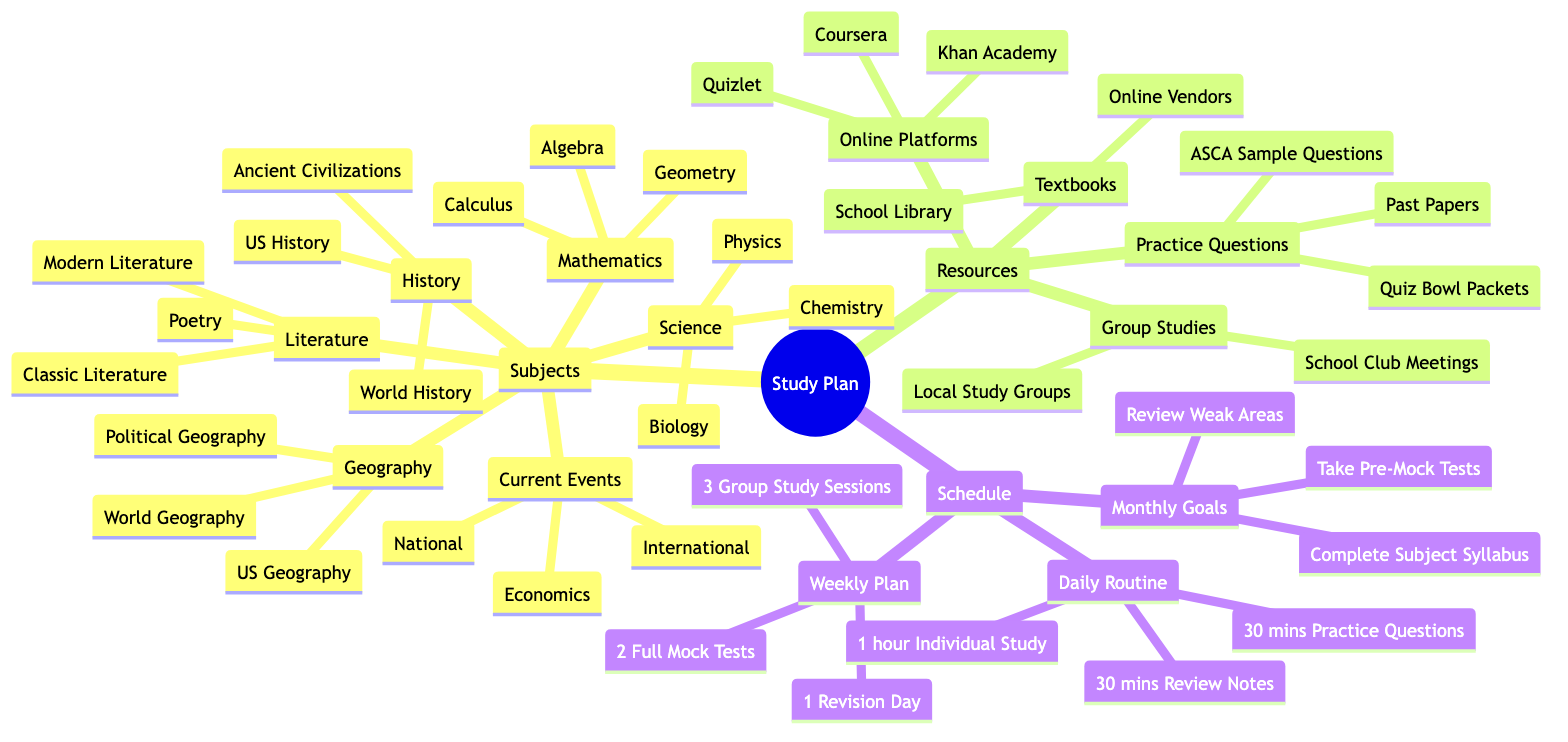What are the three main subjects listed in the Mind Map? The main subjects can be found under the “Subjects” branch of the Mind Map, which includes Mathematics, Science, Literature, History, Geography, and Current Events. Focusing on just three gives an example of Mathematics, Science, and Literature.
Answer: Mathematics, Science, Literature How many subbranches does the "Resources" branch have? The “Resources” branch contains four subbranches: Textbooks, Online Platforms, Practice Questions, and Group Studies. Therefore, counting them gives a total of four.
Answer: 4 Which subject has subbranches that include "Biology," "Chemistry," and "Physics"? The subbranches in question belong to the “Science” subject. Referring to the Mind Map, these specific terms are listed directly under the “Science” category.
Answer: Science What is the duration of the "Daily Routine" activity for individual study? Under the "Daily Routine" section, the plan specifies “1 hour Individual Study.” Therefore, the duration indicated is one hour.
Answer: 1 hour What are the three components of the "Monthly Goals" in the schedule? Looking under the "Monthly Goals" subbranch, the components are: Complete Subject Syllabus, Review Weak Areas, and Take Pre-Mock Tests. Thus, these three make up the monthly goals.
Answer: Complete Subject Syllabus, Review Weak Areas, Take Pre-Mock Tests If I participate in all the "Weekly Plan" activities, how many group study sessions will I attend? The “Weekly Plan” branch indicates there are “3 Group Study Sessions,” which means by participating fully in this segment, a total of three sessions will be attended.
Answer: 3 Which resource includes both "School Library" and "Online Vendors"? The resources that contain these two specific items are under the “Textbooks” subbranch. Both the School Library and Online Vendors are immediate subbranches under Textbooks.
Answer: Textbooks What type of study does "Group Studies" encompass in the resources? The “Group Studies” resource includes “School Club Meetings” and “Local Study Groups.” This points to collaborative learning among peers as the study type in focus.
Answer: Group Studies 